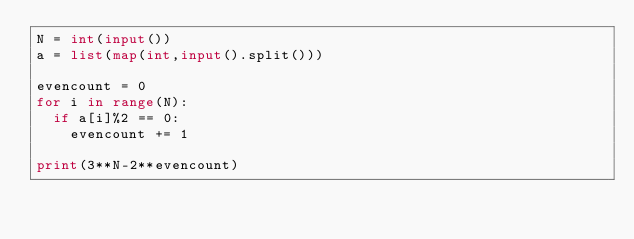Convert code to text. <code><loc_0><loc_0><loc_500><loc_500><_Python_>N = int(input())
a = list(map(int,input().split()))

evencount = 0
for i in range(N):
  if a[i]%2 == 0:
    evencount += 1

print(3**N-2**evencount)</code> 